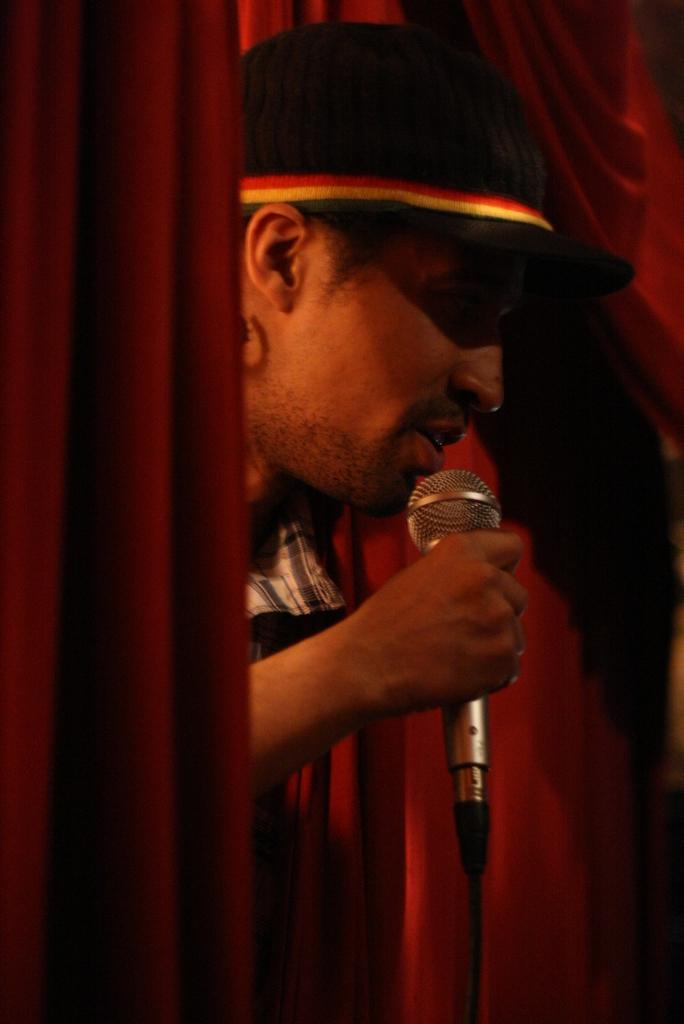What type of items can be seen in the image? There are clothes and a cap in the image. Who is present in the image? There is a man in the image. What is the man holding in his hand? The man is holding a mic with his hand. How many passengers are visible in the image? There are no passengers present in the image; it features a man holding a mic. What type of secretary can be seen working in the image? There is no secretary present in the image; it features a man holding a mic. 